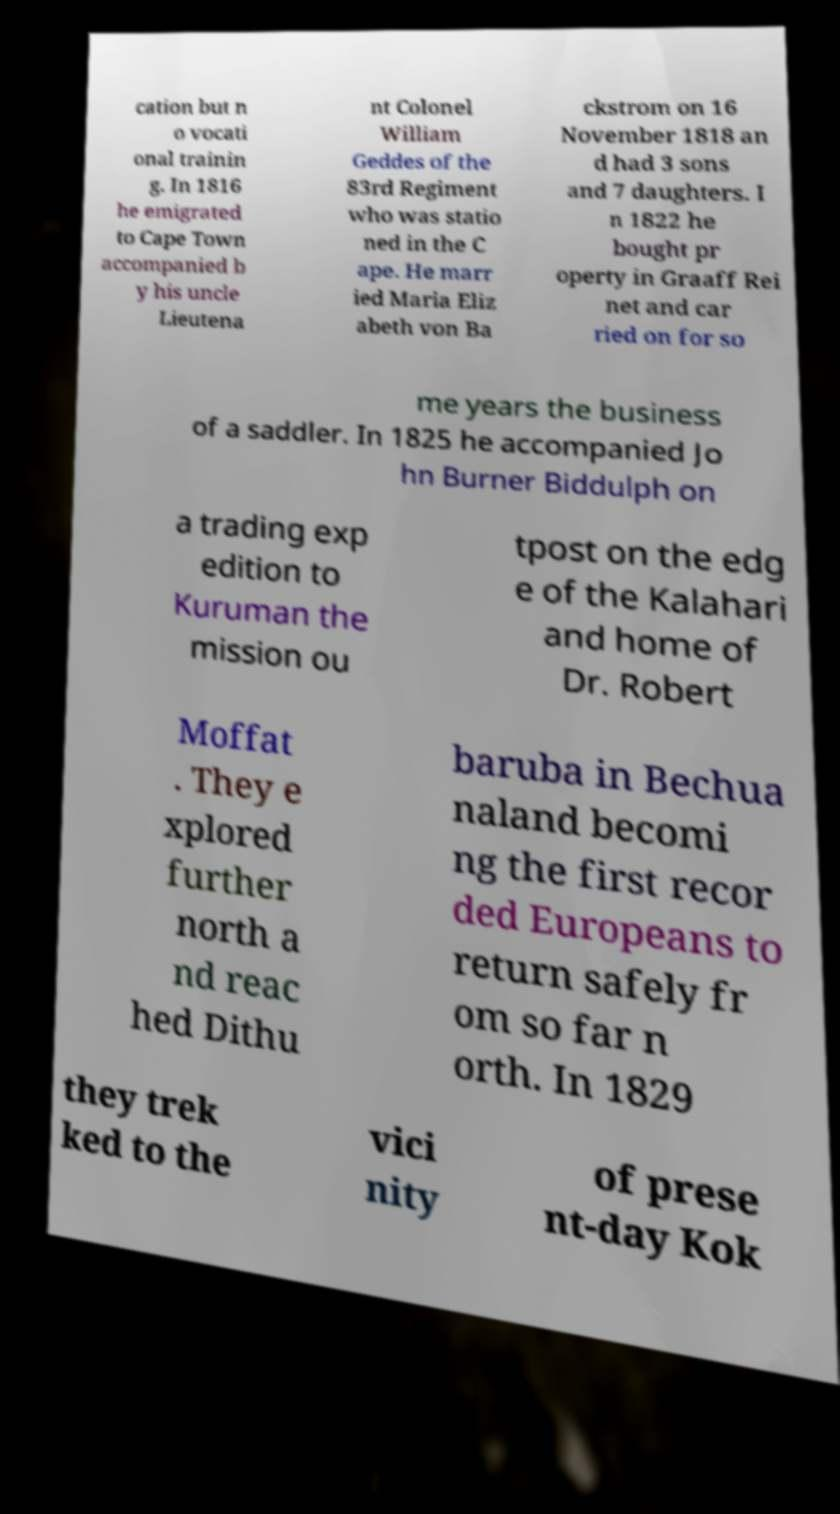Please read and relay the text visible in this image. What does it say? cation but n o vocati onal trainin g. In 1816 he emigrated to Cape Town accompanied b y his uncle Lieutena nt Colonel William Geddes of the 83rd Regiment who was statio ned in the C ape. He marr ied Maria Eliz abeth von Ba ckstrom on 16 November 1818 an d had 3 sons and 7 daughters. I n 1822 he bought pr operty in Graaff Rei net and car ried on for so me years the business of a saddler. In 1825 he accompanied Jo hn Burner Biddulph on a trading exp edition to Kuruman the mission ou tpost on the edg e of the Kalahari and home of Dr. Robert Moffat . They e xplored further north a nd reac hed Dithu baruba in Bechua naland becomi ng the first recor ded Europeans to return safely fr om so far n orth. In 1829 they trek ked to the vici nity of prese nt-day Kok 